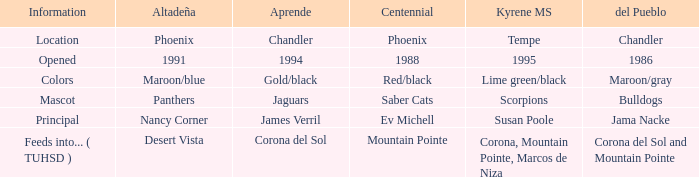Which type of aprende features a 1988 centennial? 1994.0. 